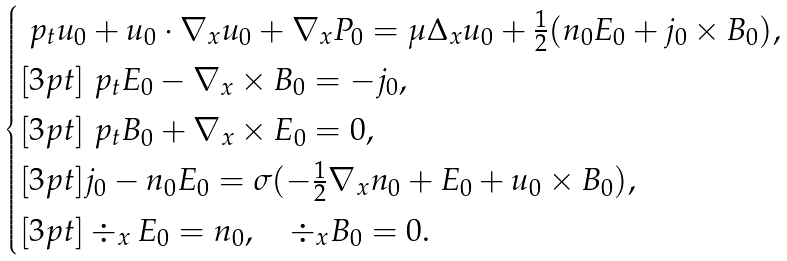<formula> <loc_0><loc_0><loc_500><loc_500>\begin{cases} \ p _ { t } u _ { 0 } + u _ { 0 } \cdot \nabla _ { x } u _ { 0 } + \nabla _ { x } P _ { 0 } = \mu \Delta _ { x } u _ { 0 } + \frac { 1 } { 2 } ( n _ { 0 } E _ { 0 } + j _ { 0 } \times B _ { 0 } ) , \\ [ 3 p t ] \ p _ { t } E _ { 0 } - \nabla _ { x } \times B _ { 0 } = - j _ { 0 } , \\ [ 3 p t ] \ p _ { t } B _ { 0 } + \nabla _ { x } \times E _ { 0 } = 0 , \\ [ 3 p t ] j _ { 0 } - n _ { 0 } E _ { 0 } = \sigma ( - \frac { 1 } { 2 } \nabla _ { x } n _ { 0 } + E _ { 0 } + u _ { 0 } \times B _ { 0 } ) , \\ [ 3 p t ] \div _ { x } E _ { 0 } = n _ { 0 } , \quad \div _ { x } B _ { 0 } = 0 . \end{cases}</formula> 